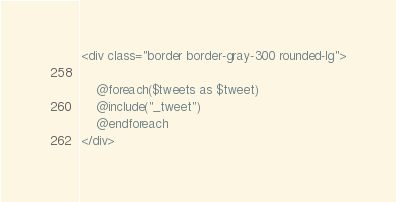<code> <loc_0><loc_0><loc_500><loc_500><_PHP_><div class="border border-gray-300 rounded-lg">
            
    @foreach($tweets as $tweet)
    @include("_tweet")
    @endforeach
</div></code> 